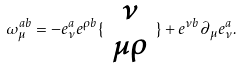<formula> <loc_0><loc_0><loc_500><loc_500>\omega _ { \mu } ^ { a b } = - e _ { \nu } ^ { a } e ^ { \rho b } \{ \begin{array} { c } \nu \\ \mu \rho \end{array} \} + e ^ { \nu b } \partial _ { \mu } e _ { \nu } ^ { a } .</formula> 